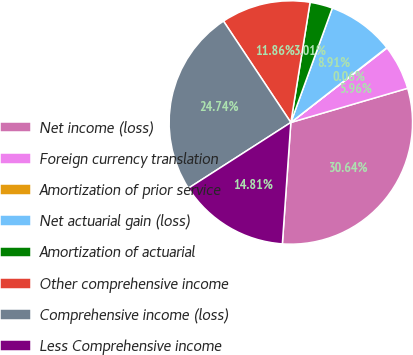<chart> <loc_0><loc_0><loc_500><loc_500><pie_chart><fcel>Net income (loss)<fcel>Foreign currency translation<fcel>Amortization of prior service<fcel>Net actuarial gain (loss)<fcel>Amortization of actuarial<fcel>Other comprehensive income<fcel>Comprehensive income (loss)<fcel>Less Comprehensive income<nl><fcel>30.64%<fcel>5.96%<fcel>0.06%<fcel>8.91%<fcel>3.01%<fcel>11.86%<fcel>24.74%<fcel>14.81%<nl></chart> 